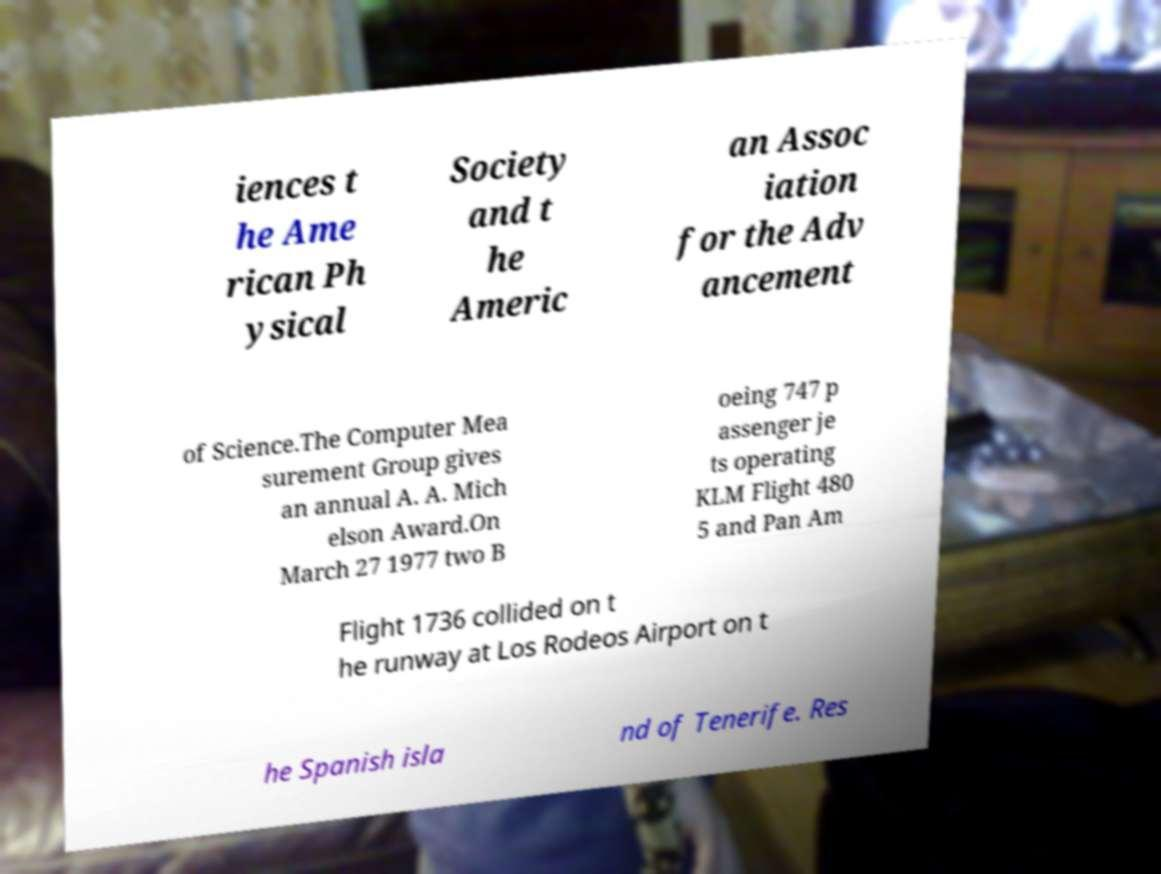There's text embedded in this image that I need extracted. Can you transcribe it verbatim? iences t he Ame rican Ph ysical Society and t he Americ an Assoc iation for the Adv ancement of Science.The Computer Mea surement Group gives an annual A. A. Mich elson Award.On March 27 1977 two B oeing 747 p assenger je ts operating KLM Flight 480 5 and Pan Am Flight 1736 collided on t he runway at Los Rodeos Airport on t he Spanish isla nd of Tenerife. Res 